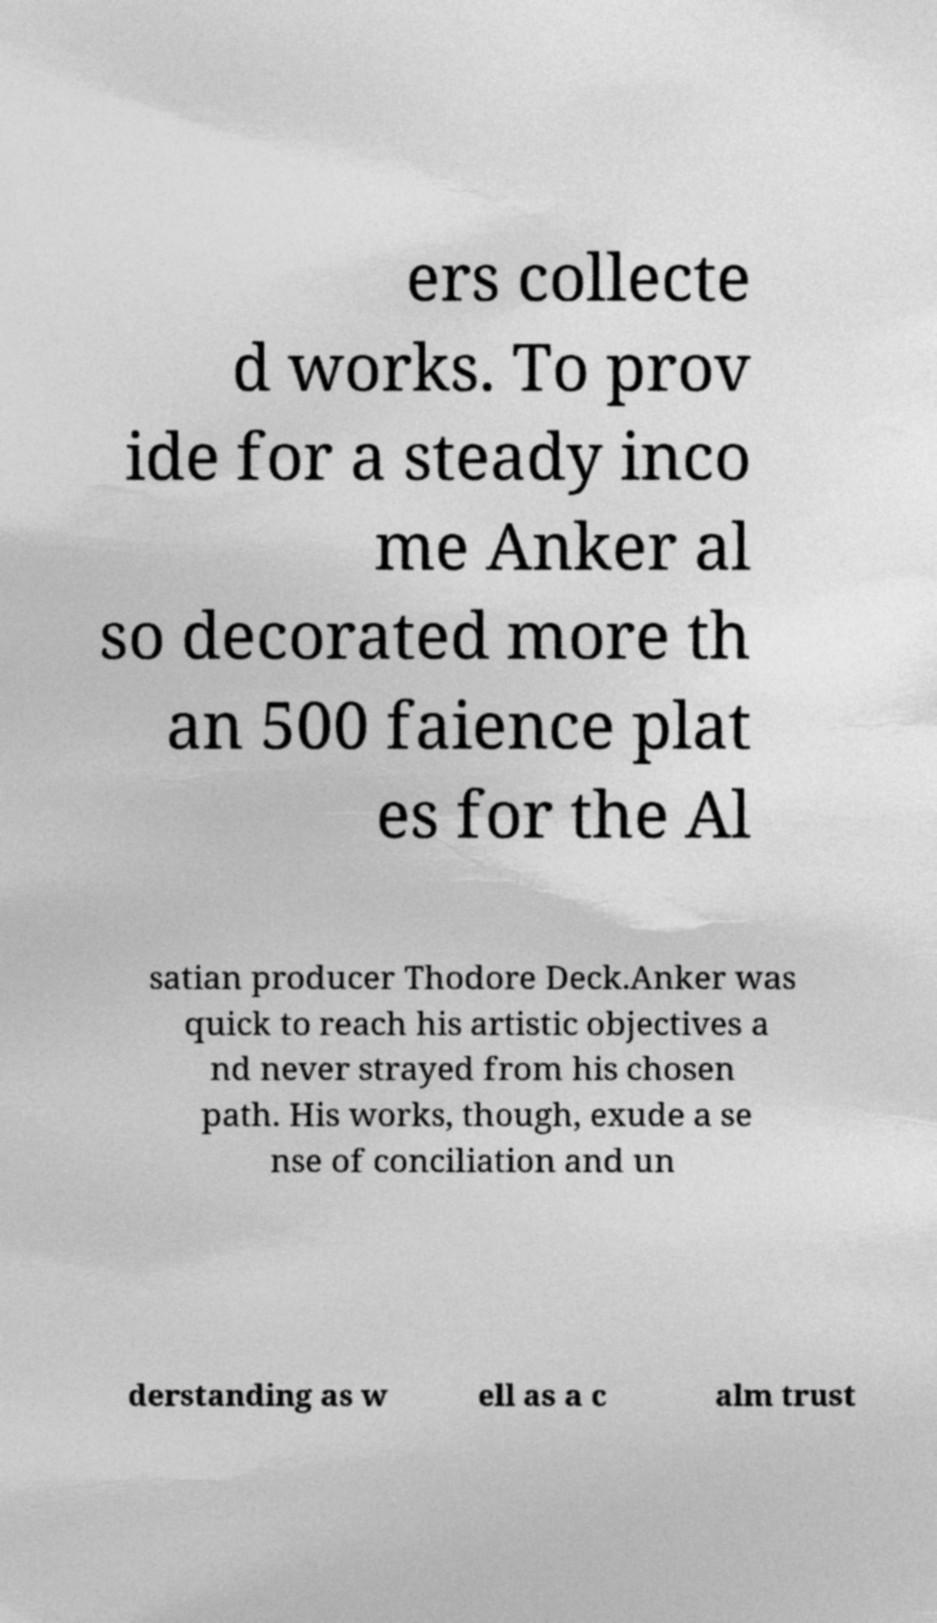What messages or text are displayed in this image? I need them in a readable, typed format. ers collecte d works. To prov ide for a steady inco me Anker al so decorated more th an 500 faience plat es for the Al satian producer Thodore Deck.Anker was quick to reach his artistic objectives a nd never strayed from his chosen path. His works, though, exude a se nse of conciliation and un derstanding as w ell as a c alm trust 